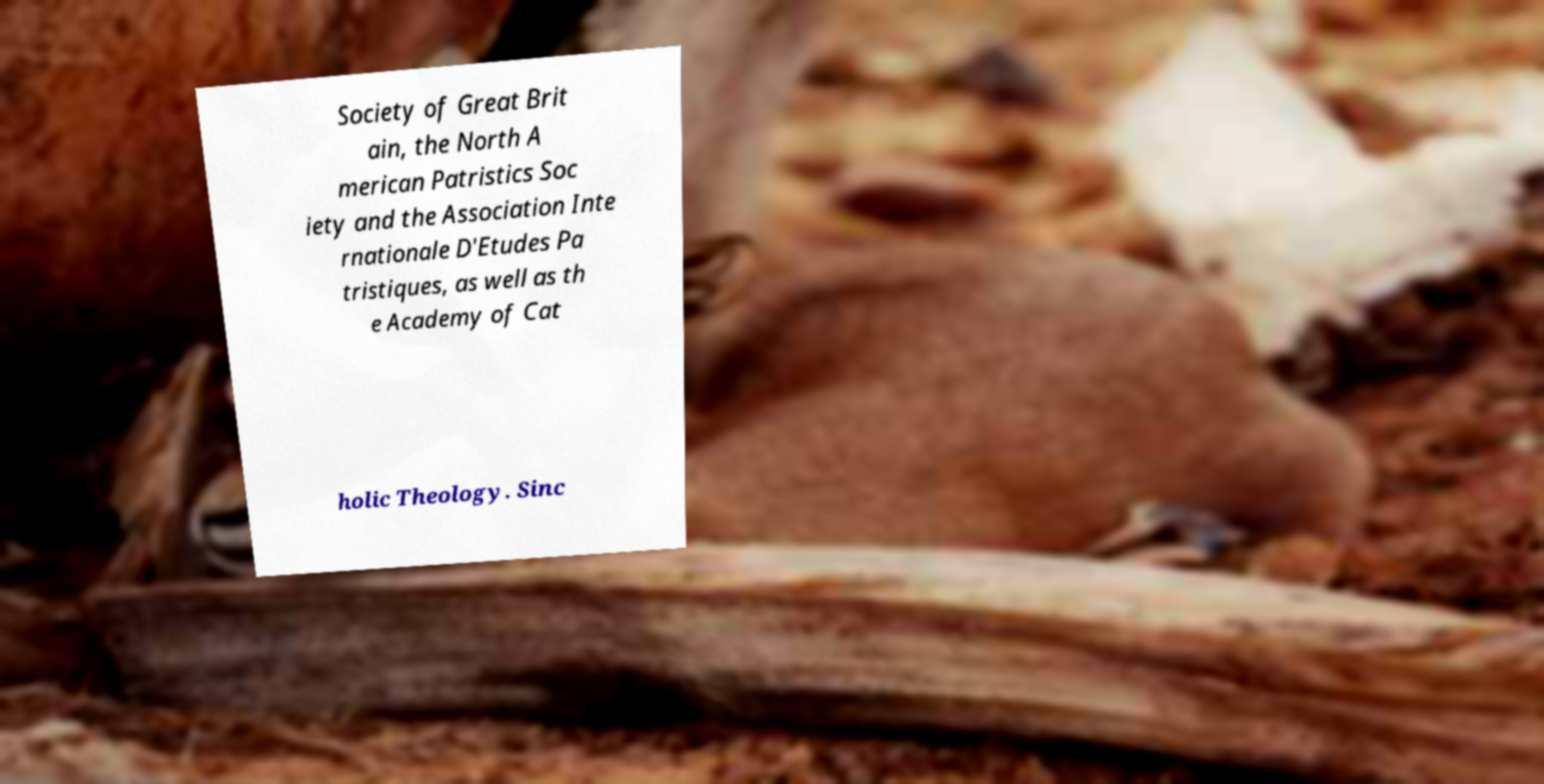Can you accurately transcribe the text from the provided image for me? Society of Great Brit ain, the North A merican Patristics Soc iety and the Association Inte rnationale D'Etudes Pa tristiques, as well as th e Academy of Cat holic Theology. Sinc 